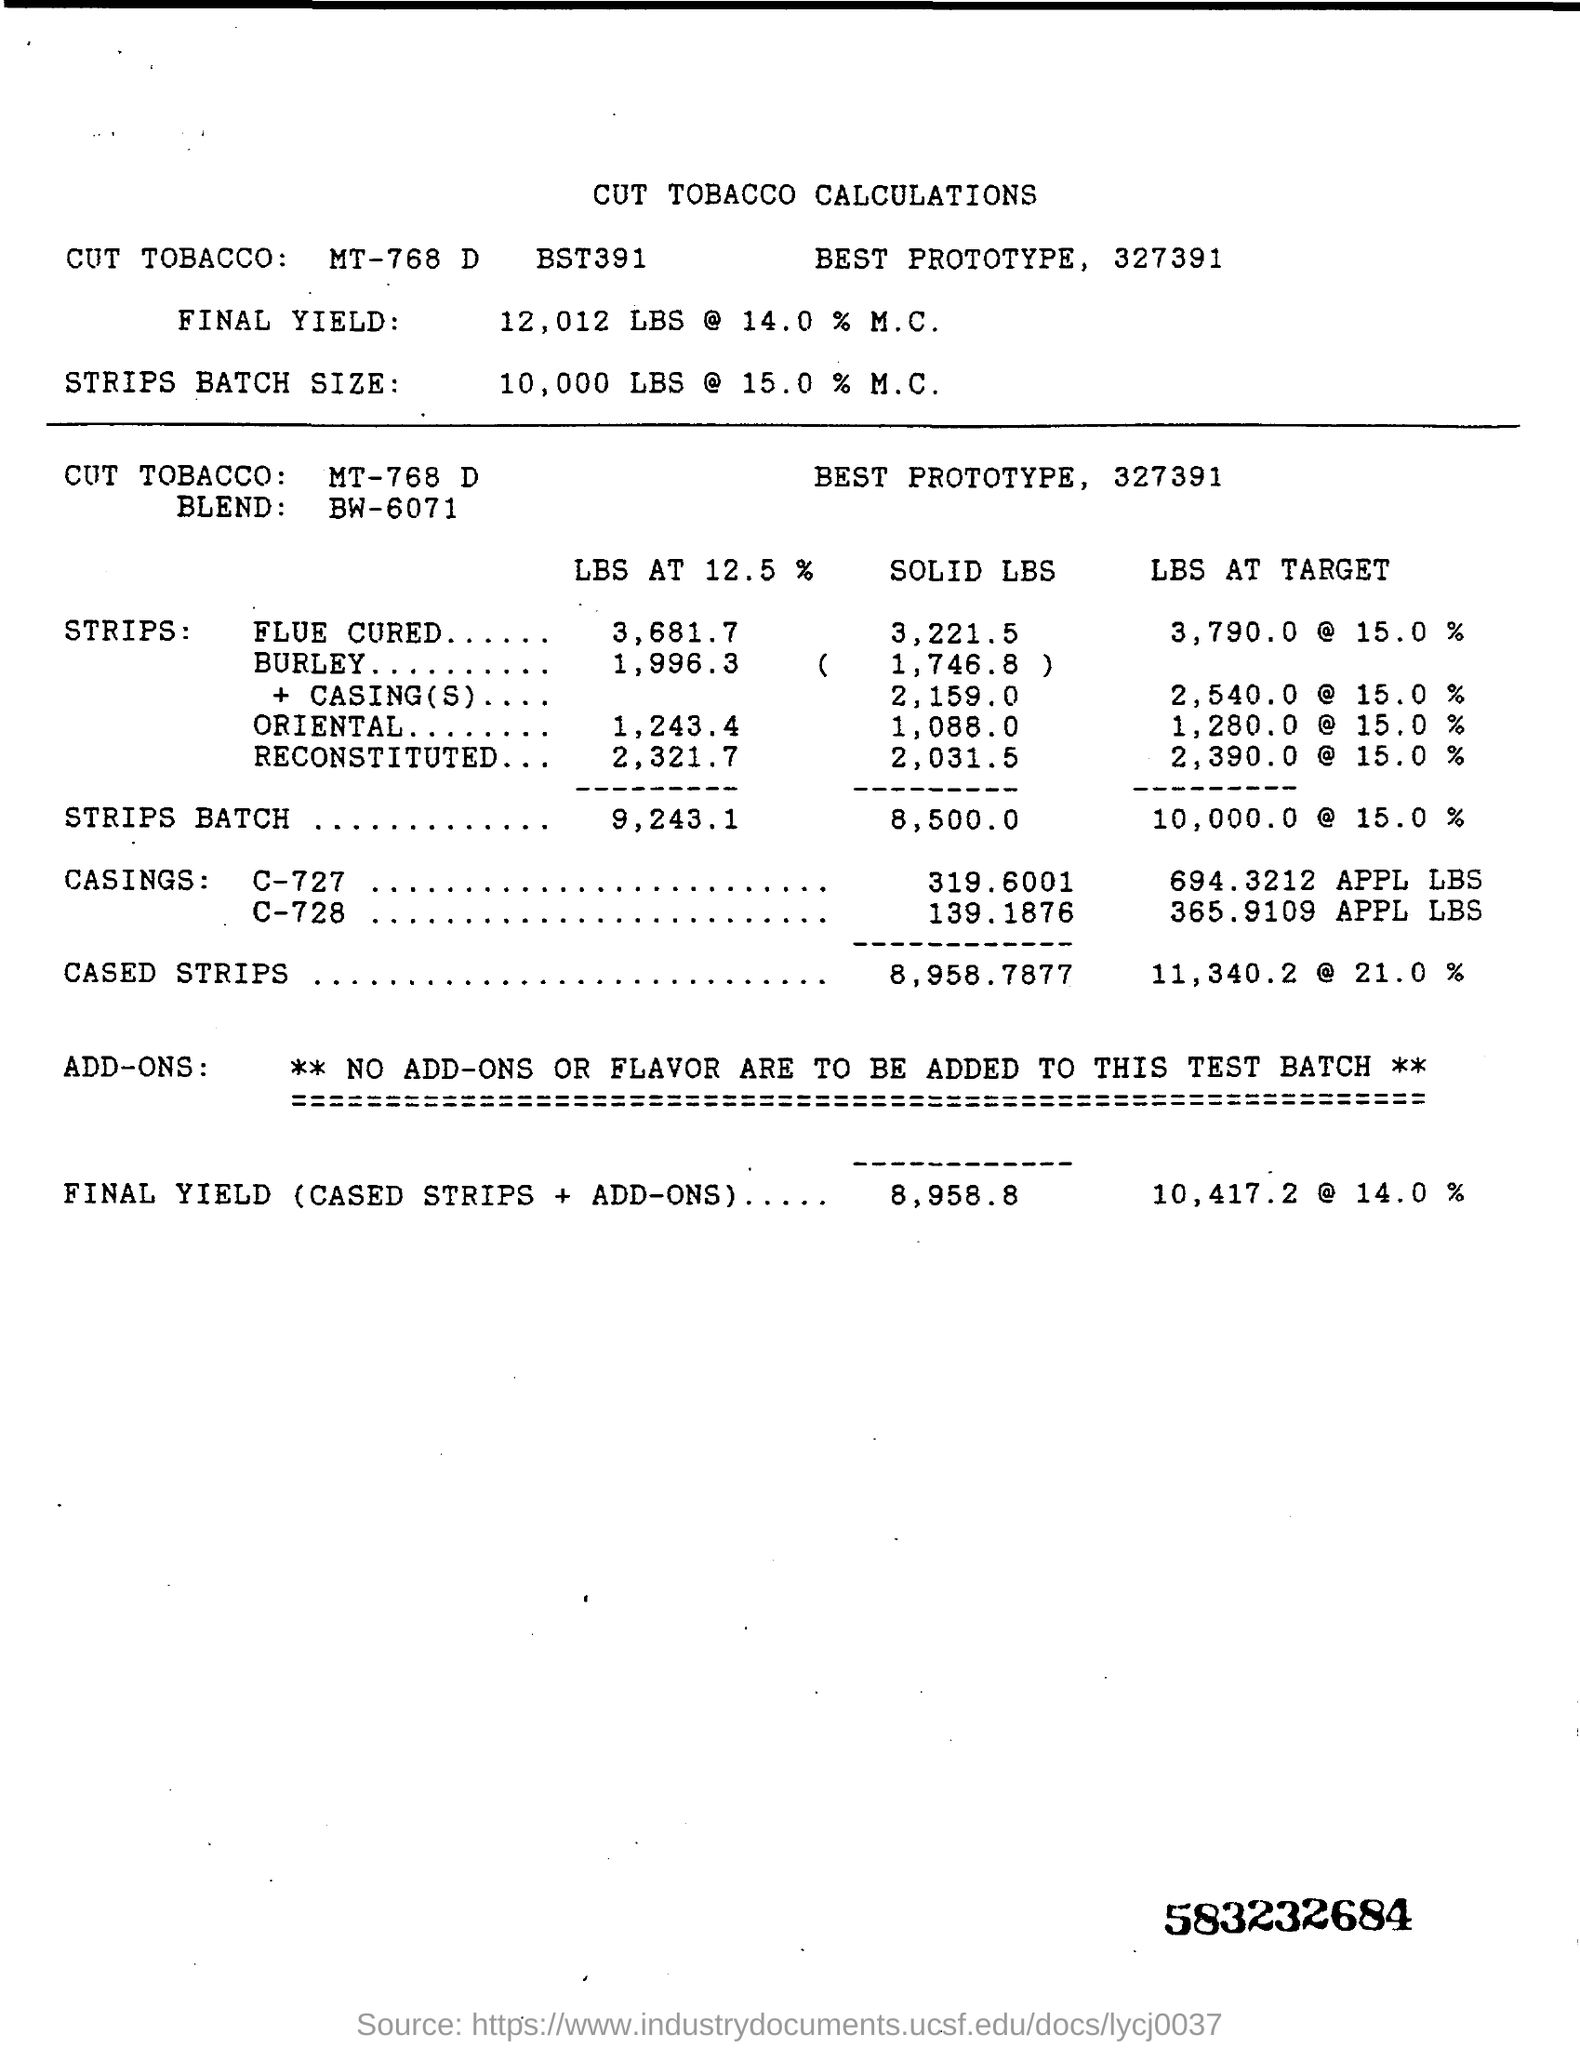Outline some significant characteristics in this image. What code is mentioned in the bottom right corner?" is a question. "583232684.." is a code. The title is "What is the title? CUT TOBACCO CALCULATIONS.. 